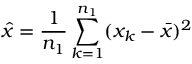Convert formula to latex. <formula><loc_0><loc_0><loc_500><loc_500>\hat { x } = \frac { 1 } { n _ { 1 } } \sum _ { k = 1 } ^ { n _ { 1 } } ( x _ { k } - \bar { x } ) ^ { 2 }</formula> 